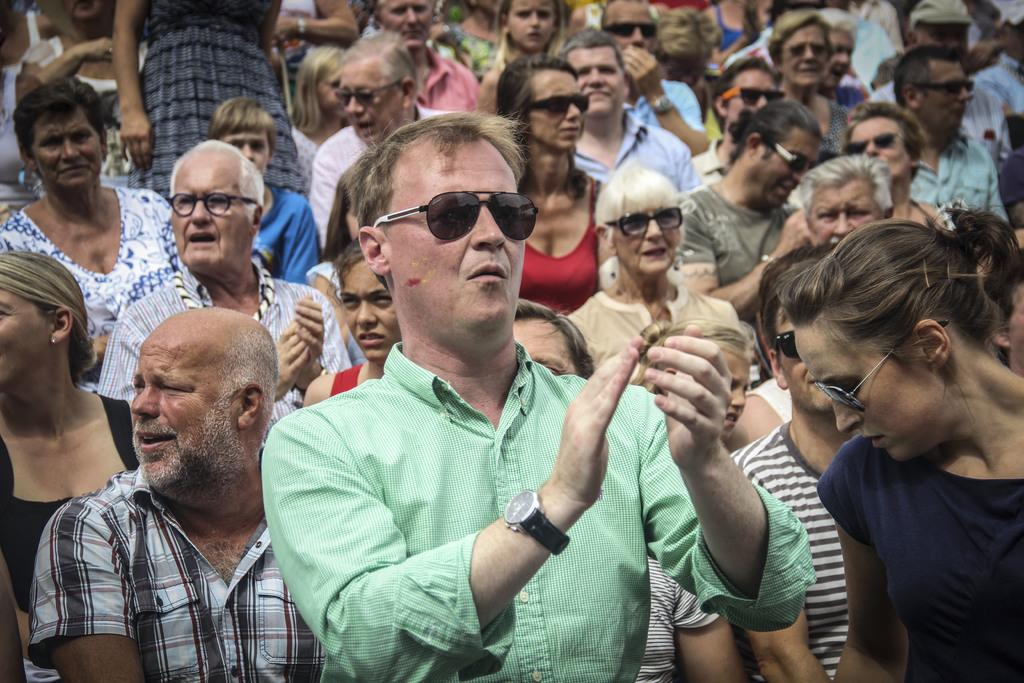How many people are in the image? There are multiple people in the image. What type of accessory are most of the people wearing? Most of the people in the image are wearing shades. What type of advice is being exchanged between the people in the image? There is no indication in the image that any advice is being exchanged between the people. 